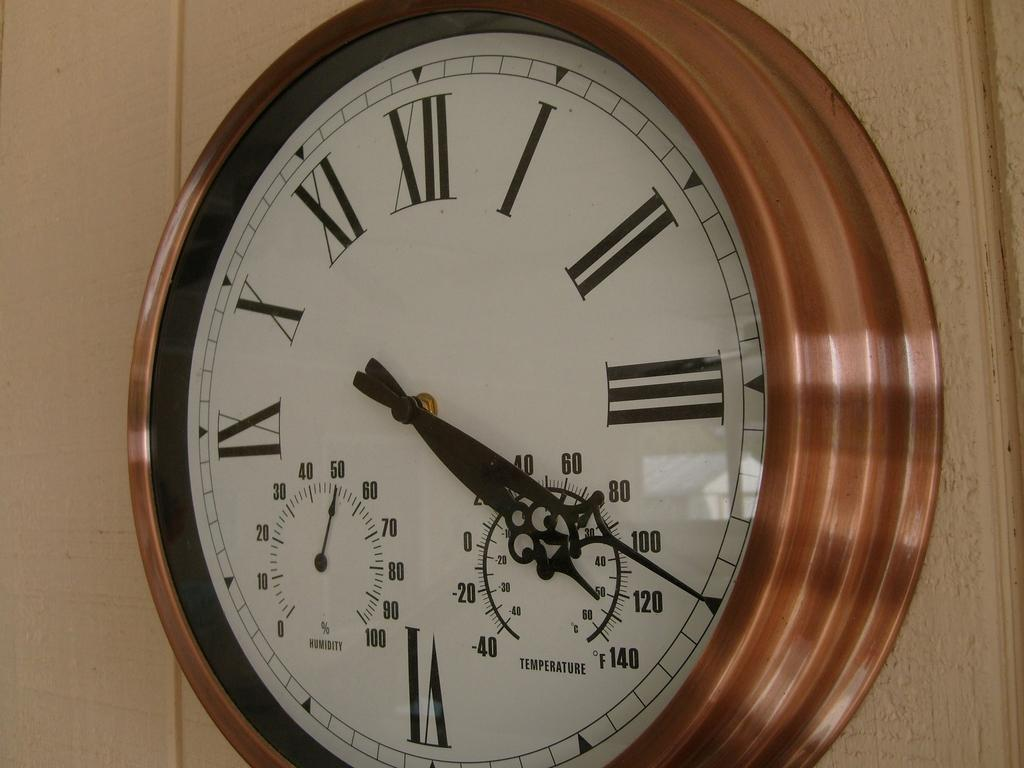<image>
Give a short and clear explanation of the subsequent image. A wall clock has the time of 4:20 and humidity of 50%. 